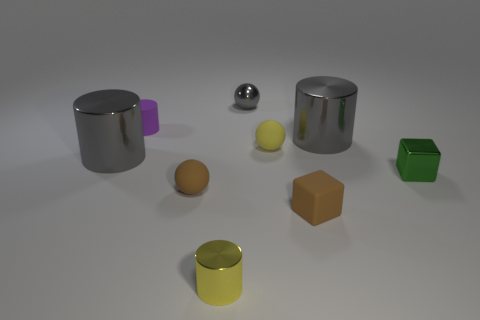Subtract all metallic cylinders. How many cylinders are left? 1 Subtract all brown blocks. How many blocks are left? 1 Subtract all blocks. How many objects are left? 7 Add 1 green spheres. How many objects exist? 10 Subtract 3 cylinders. How many cylinders are left? 1 Subtract all small green blocks. Subtract all yellow things. How many objects are left? 6 Add 1 small matte cylinders. How many small matte cylinders are left? 2 Add 9 yellow cylinders. How many yellow cylinders exist? 10 Subtract 1 gray cylinders. How many objects are left? 8 Subtract all purple cylinders. Subtract all purple spheres. How many cylinders are left? 3 